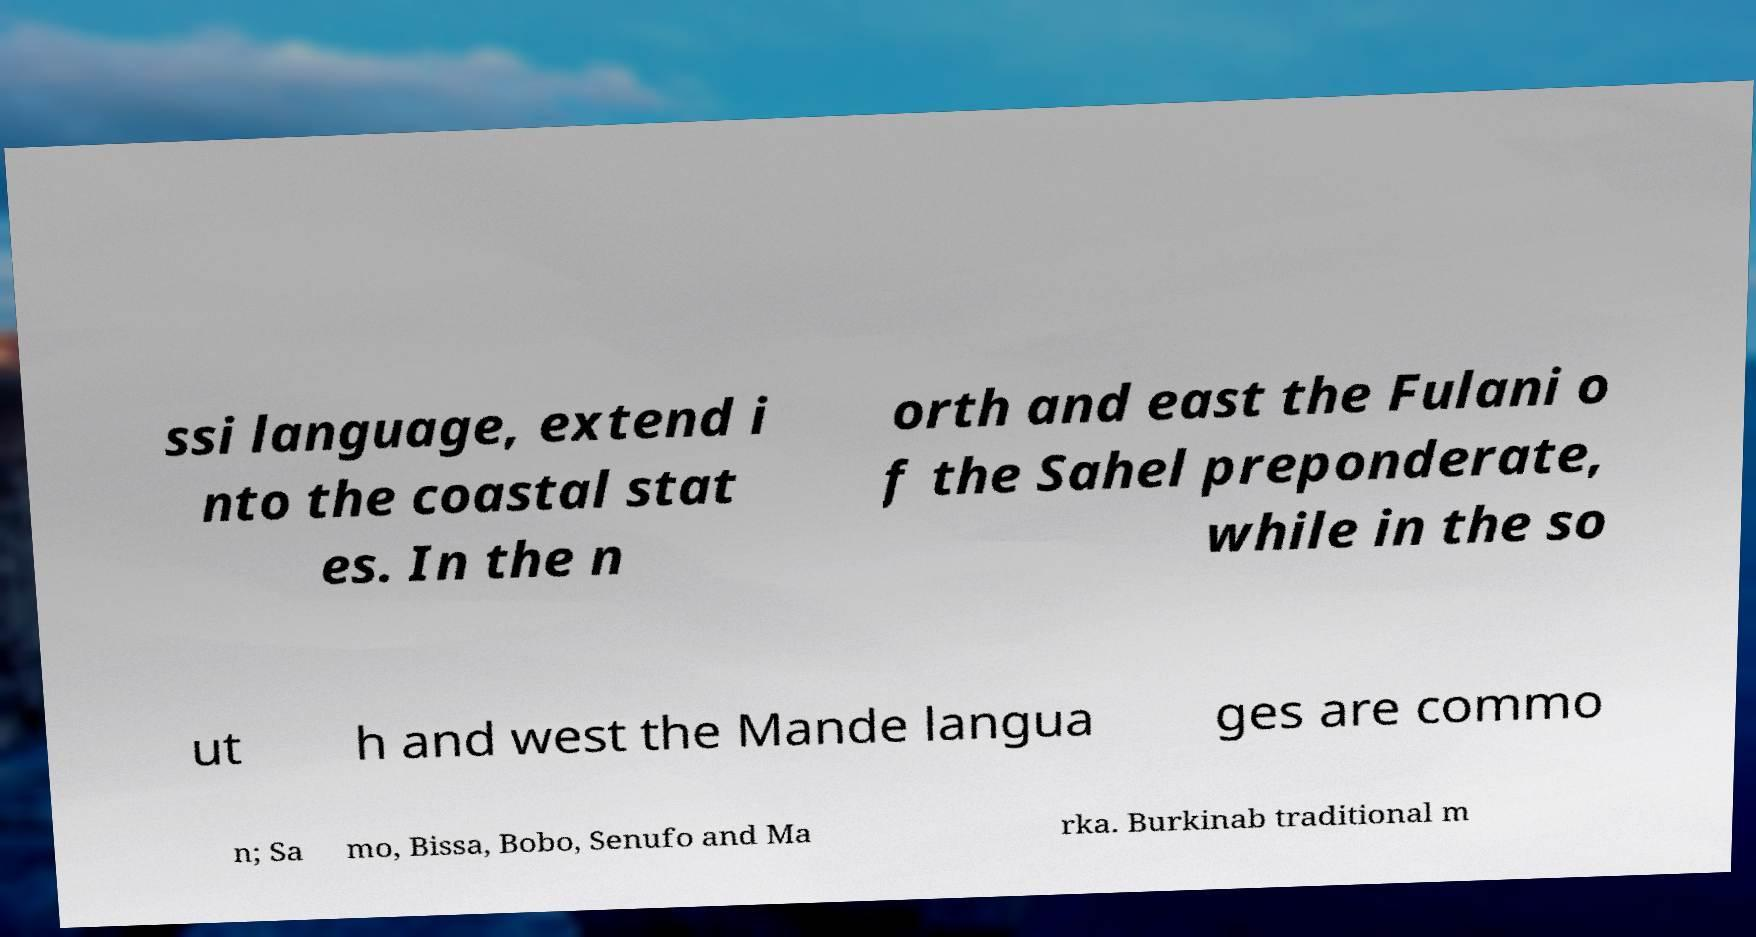Could you extract and type out the text from this image? ssi language, extend i nto the coastal stat es. In the n orth and east the Fulani o f the Sahel preponderate, while in the so ut h and west the Mande langua ges are commo n; Sa mo, Bissa, Bobo, Senufo and Ma rka. Burkinab traditional m 